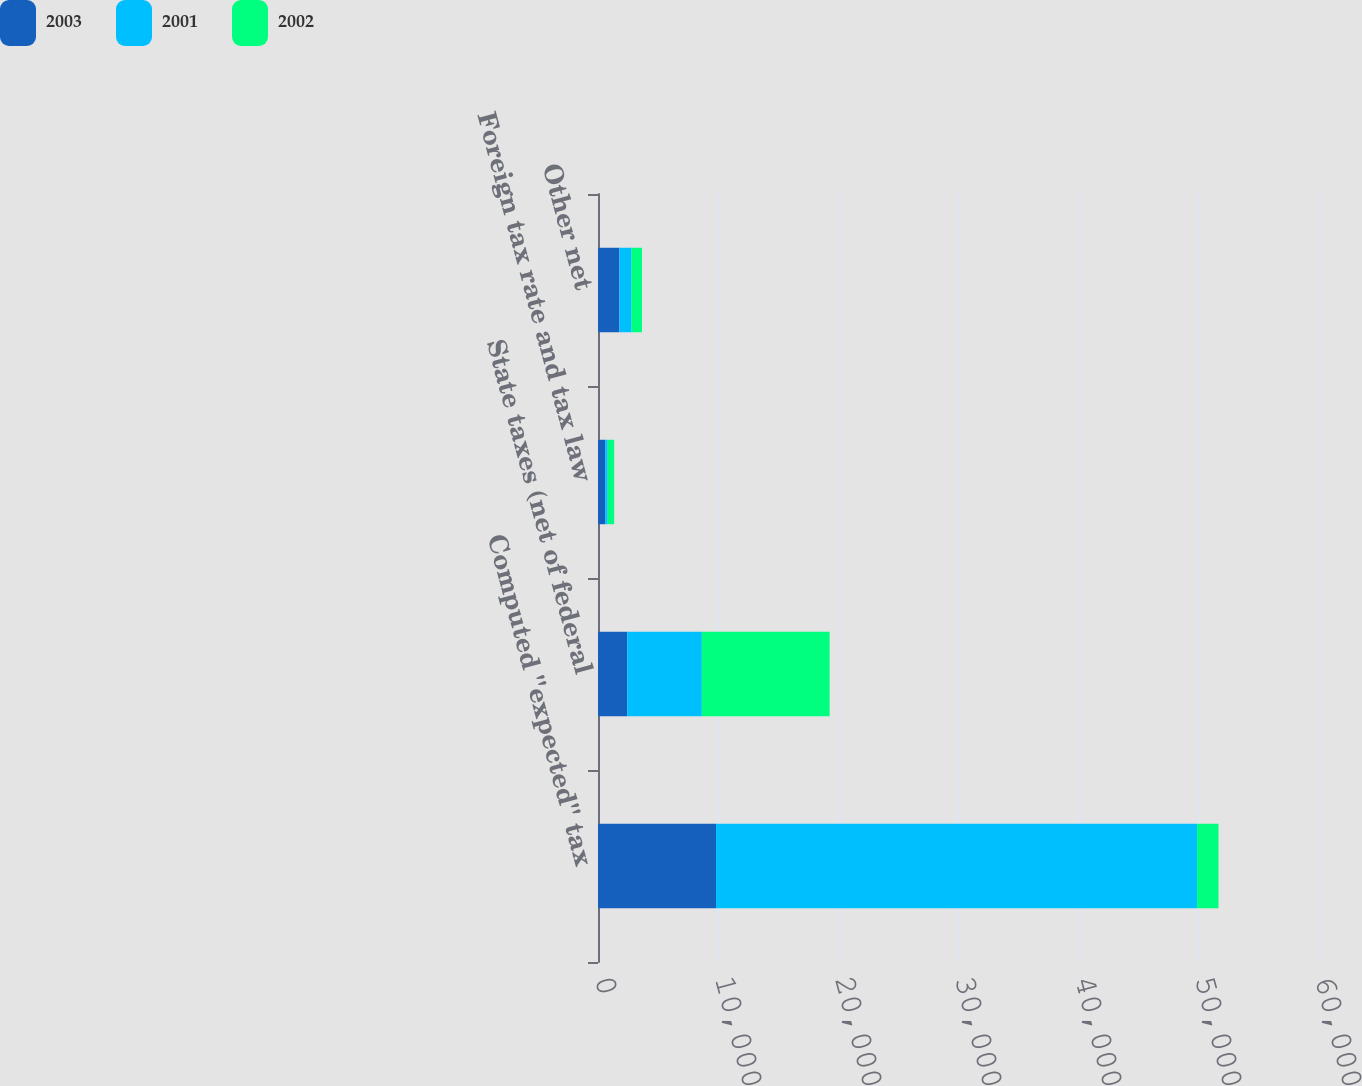Convert chart. <chart><loc_0><loc_0><loc_500><loc_500><stacked_bar_chart><ecel><fcel>Computed ''expected'' tax<fcel>State taxes (net of federal<fcel>Foreign tax rate and tax law<fcel>Other net<nl><fcel>2003<fcel>9838<fcel>2432<fcel>598<fcel>1785<nl><fcel>2001<fcel>40082<fcel>6220<fcel>209<fcel>1015<nl><fcel>2002<fcel>1785<fcel>10650<fcel>540<fcel>865<nl></chart> 